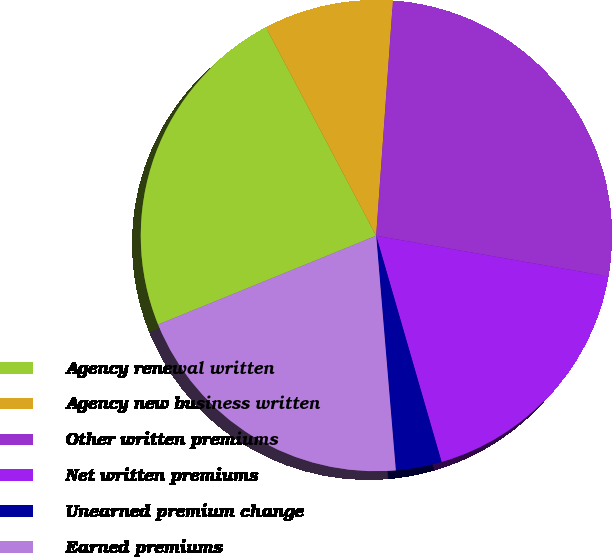Convert chart to OTSL. <chart><loc_0><loc_0><loc_500><loc_500><pie_chart><fcel>Agency renewal written<fcel>Agency new business written<fcel>Other written premiums<fcel>Net written premiums<fcel>Unearned premium change<fcel>Earned premiums<nl><fcel>23.41%<fcel>8.88%<fcel>26.63%<fcel>17.76%<fcel>3.15%<fcel>20.18%<nl></chart> 